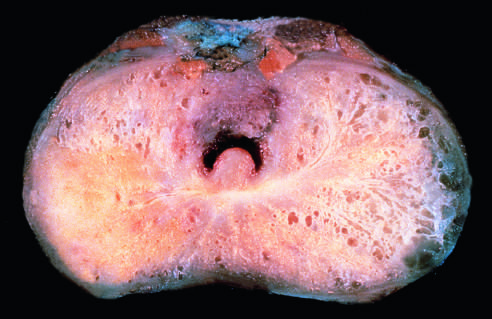s higher-power photomicrograph seen on the posterior aspect (lower left)?
Answer the question using a single word or phrase. No 